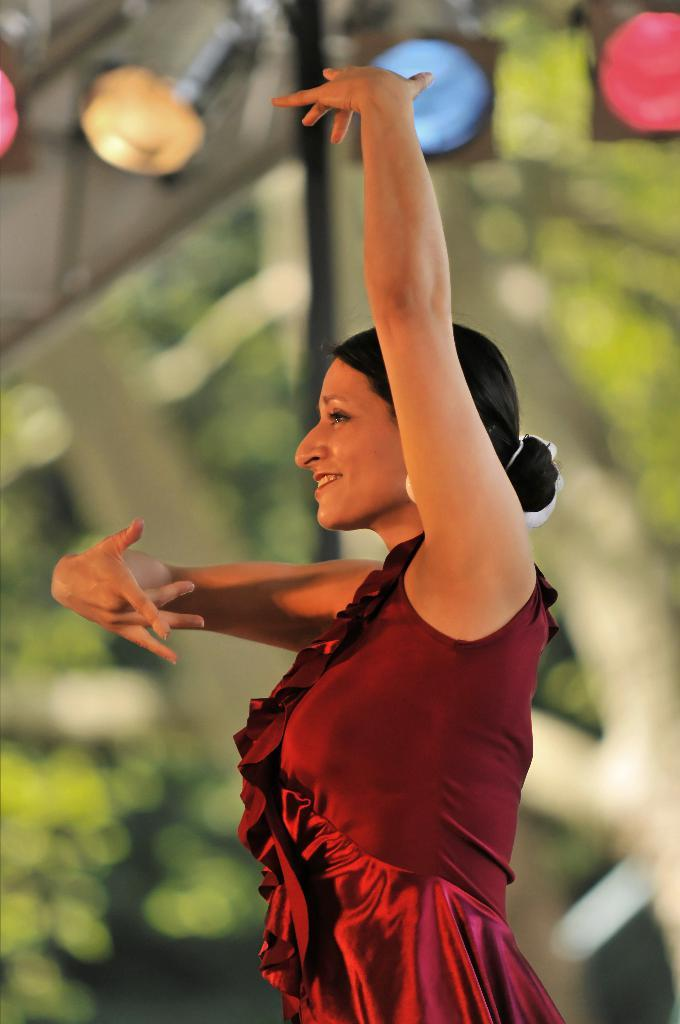Who is the main subject in the image? There is a woman in the image. What is the woman doing in the image? The woman is dancing and smiling. Can you describe the background of the image? The background of the image is blurred. How does the woman increase the system's efficiency while reading in the image? There is no mention of a system or reading in the image; the woman is dancing and smiling. 